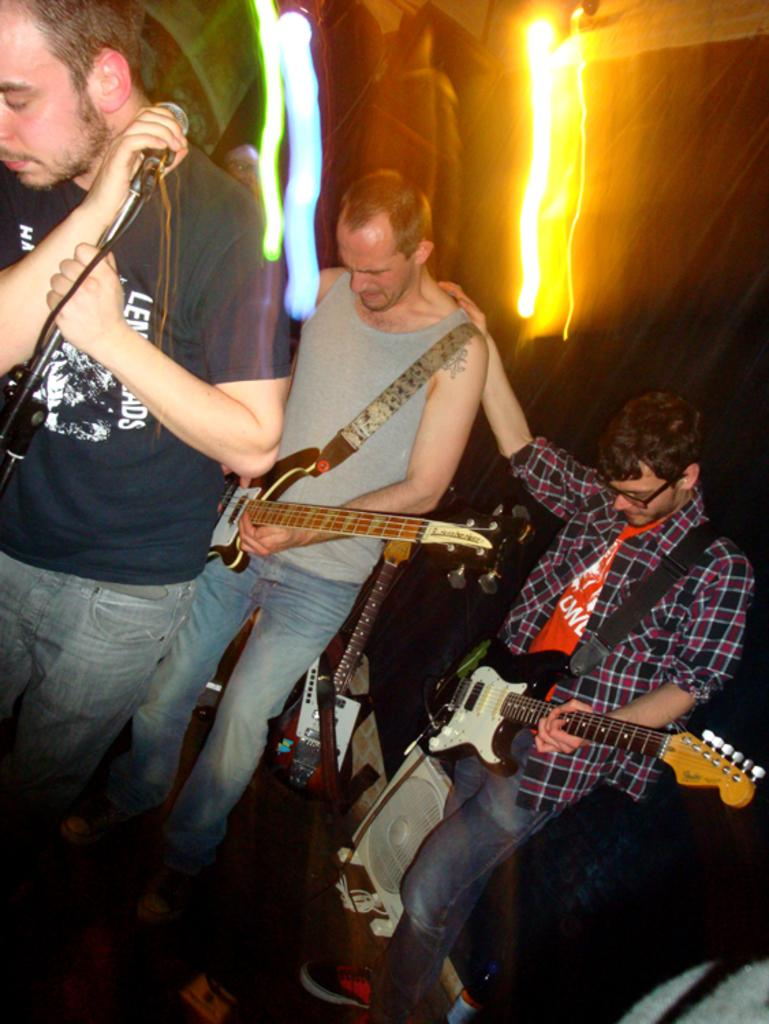How many men are in the image? There are three men in the image. What are the men doing in the image? The men are standing, and two of them are playing guitars. Is there anyone else in the image besides the men? Yes, there is a person holding a microphone. What type of metal is the microphone made of in the image? There is no information about the material of the microphone in the image, so it cannot be determined. 